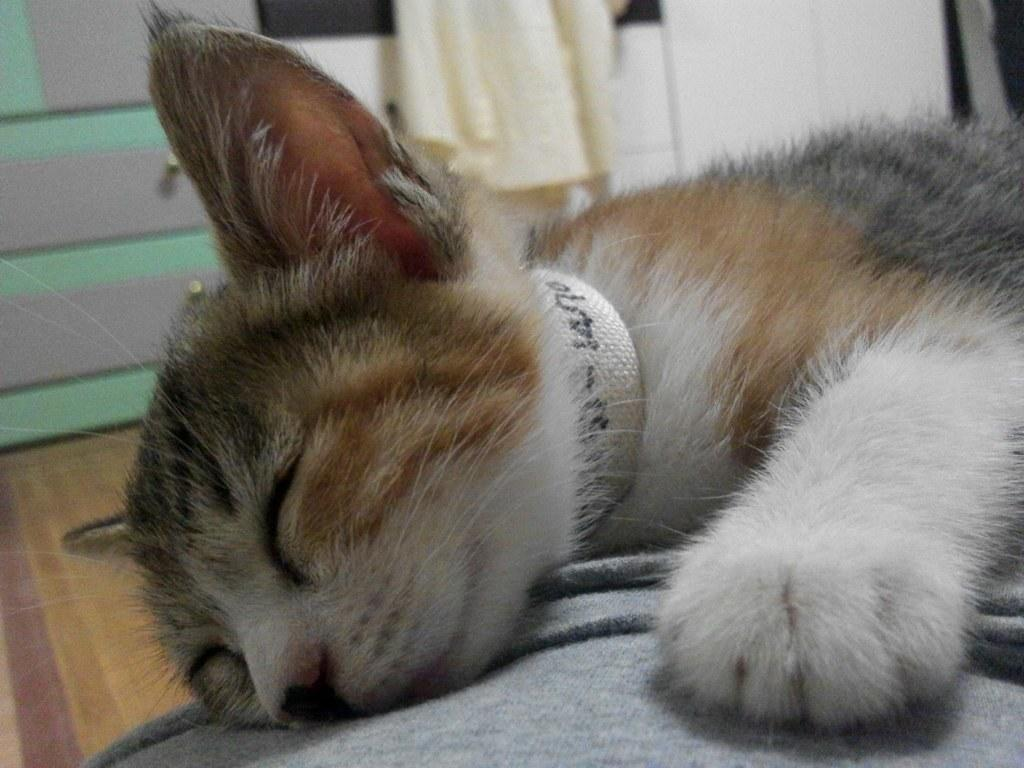What type of animal can be seen in the image? There is a cat in the image. What is the cat doing in the image? The cat is sleeping on a bed. What is located behind the cat in the image? There is a wall behind the cat. Is there any window treatment present in the image? Yes, there is a curtain associated with the wall. What type of flower is the cat using to mark its territory in the image? There is no flower present in the image, and the cat is not marking its territory. 